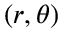Convert formula to latex. <formula><loc_0><loc_0><loc_500><loc_500>( r , \theta )</formula> 